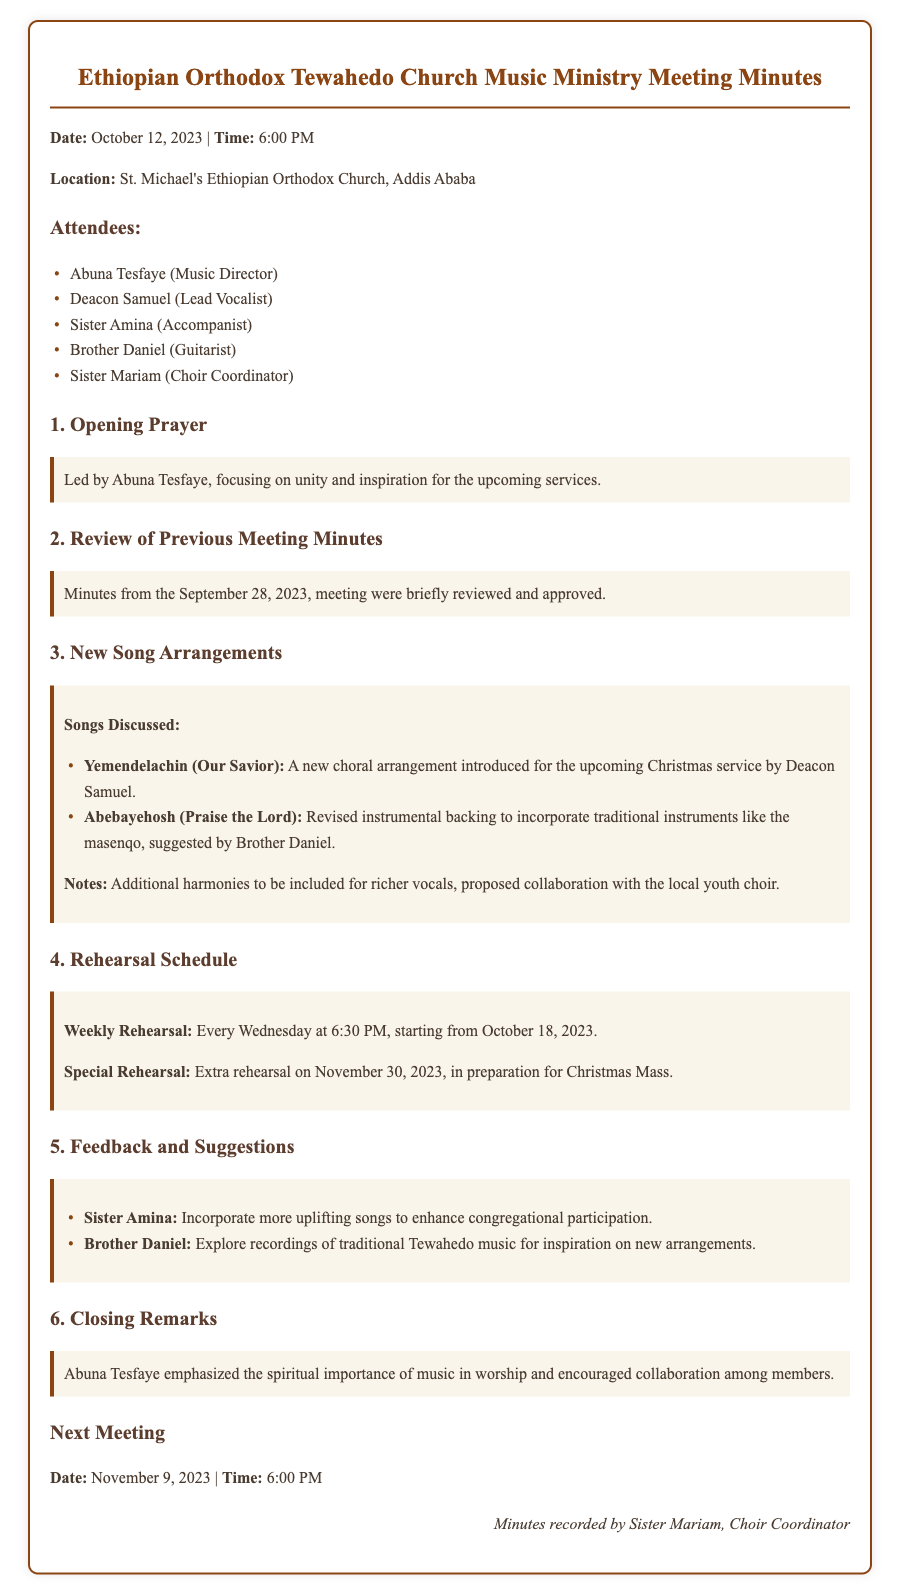What was the date of the meeting? The date of the meeting is explicitly stated at the beginning of the document.
Answer: October 12, 2023 Who led the opening prayer? The document specifies that Abuna Tesfaye led the opening prayer.
Answer: Abuna Tesfaye What new song arrangement was introduced for the upcoming Christmas service? The document discusses the introduction of a new choral arrangement for "Yemendelachin (Our Savior)."
Answer: Yemendelachin (Our Savior) What day of the week are the weekly rehearsals scheduled? The rehearsals are mentioned to occur every Wednesday according to the schedule provided.
Answer: Wednesday How many times is the special rehearsal scheduled before Christmas Mass? The document states there is one extra rehearsal scheduled specifically for Christmas Mass.
Answer: One What suggestion did Sister Amina provide during feedback? Sister Amina suggested incorporating more uplifting songs to enhance participation.
Answer: More uplifting songs What was emphasized by Abuna Tesfaye in the closing remarks? It is noted in the closing remarks that Abuna Tesfaye emphasized the spiritual importance of music.
Answer: Spiritual importance of music When is the next meeting scheduled? The next meeting details include the date and time which is provided in a specific section.
Answer: November 9, 2023 